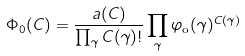Convert formula to latex. <formula><loc_0><loc_0><loc_500><loc_500>\Phi _ { 0 } ( C ) = \frac { a ( C ) } { \prod _ { \gamma } C ( \gamma ) ! } \prod _ { \gamma } \varphi _ { \text {o} } ( \gamma ) ^ { C ( \gamma ) }</formula> 